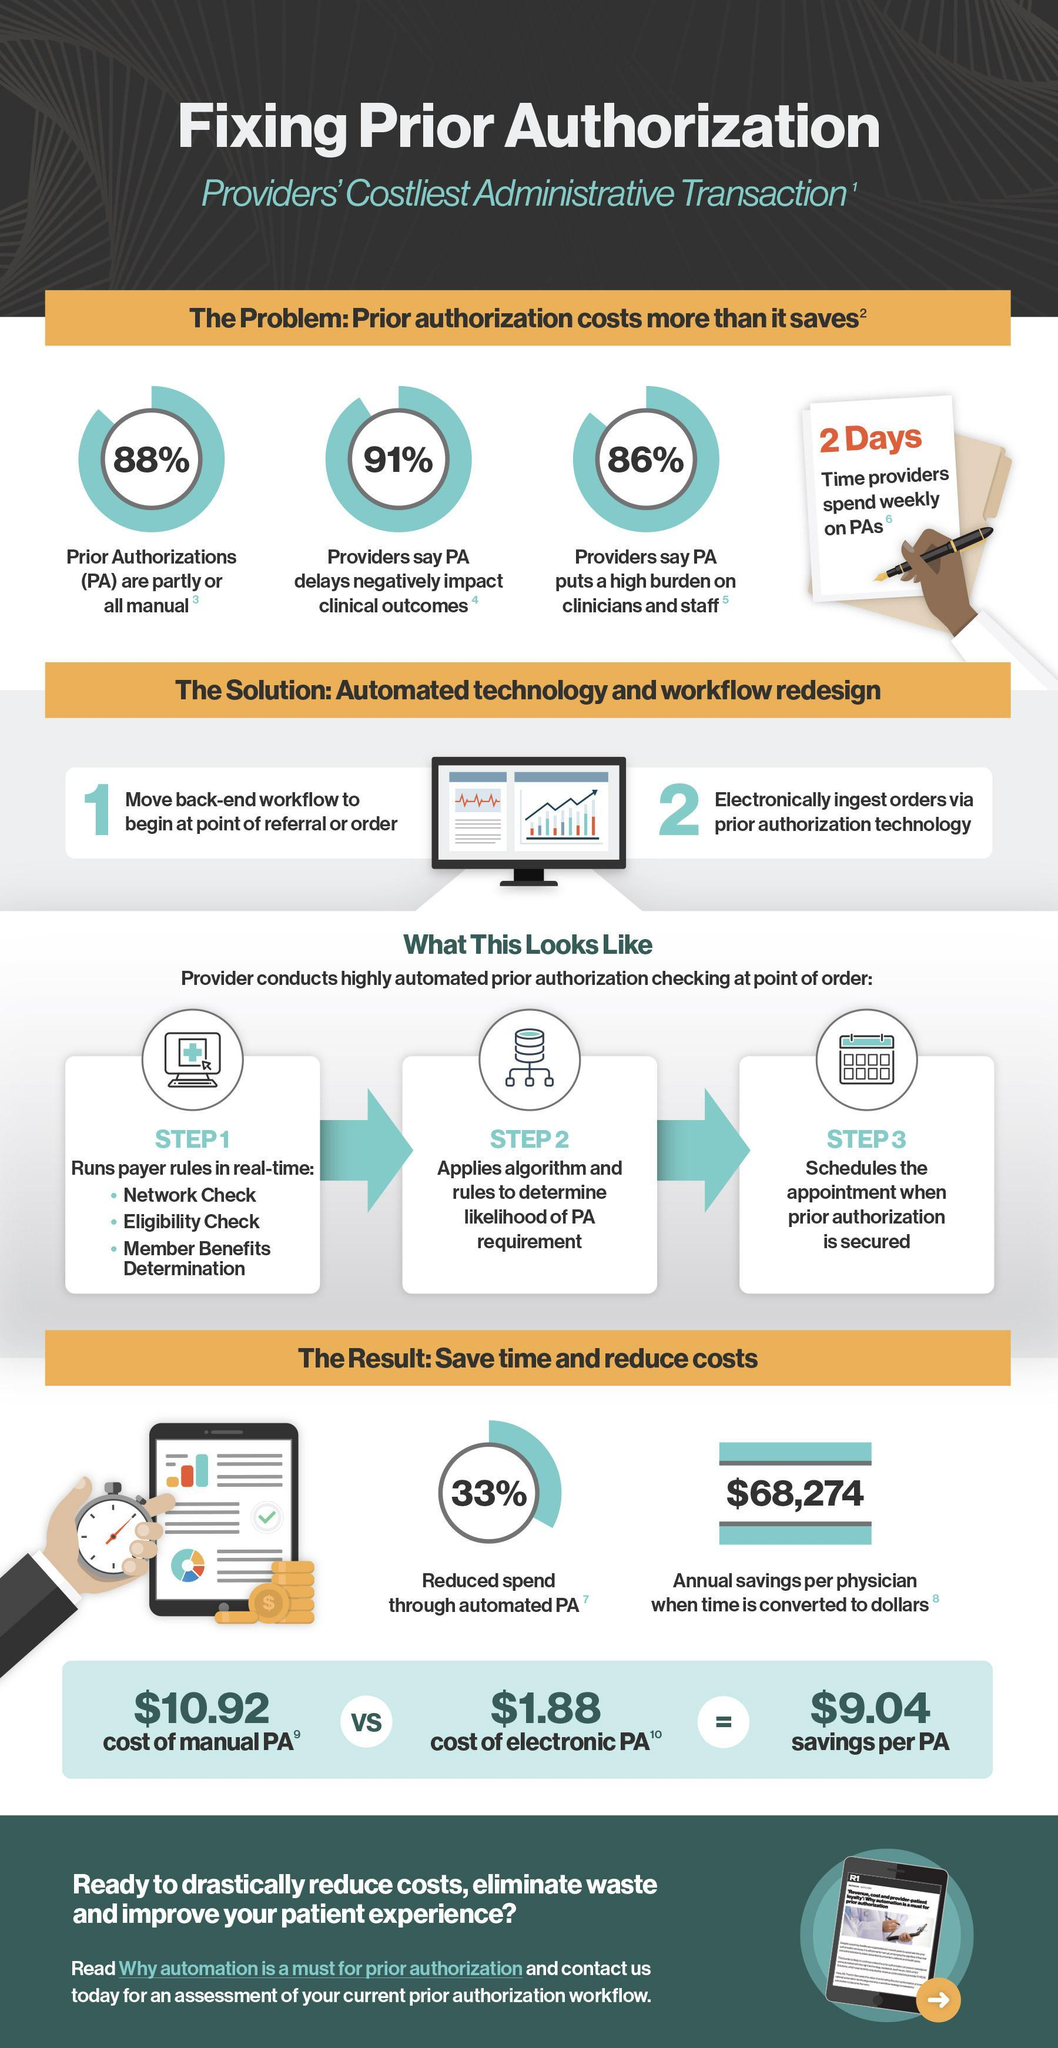How much is the annual savings per physician when time is converted to dollars
Answer the question with a short phrase. $68,274 What is the savings if we shift from a manual PA to an electronic PA $9.04 how much time do time providers spend weekly on PAs 2 days WHat % of PA are partly or all manual 88% 